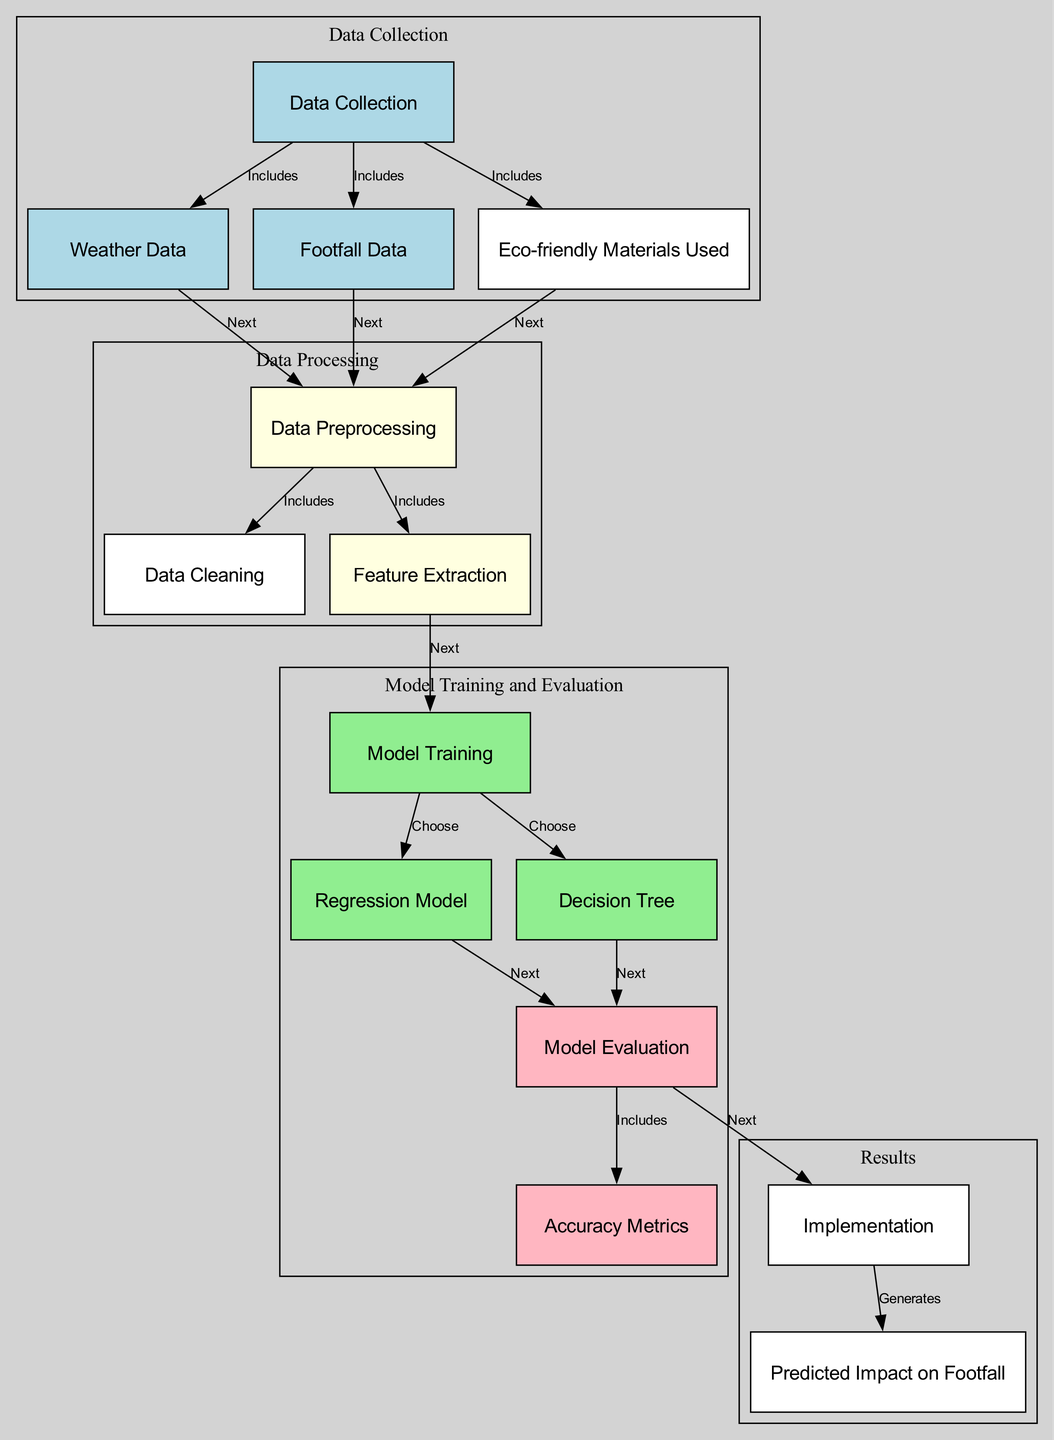What nodes are included in the data collection phase? The diagram directly lists "weather data," "footfall data," and "eco-friendly materials used" as nodes that are part of the data collection phase under the "data_collection" node.
Answer: weather data, footfall data, eco-friendly materials used How many edges connect the preprocessing node? By looking at the diagram, the "preprocessing" node has three outgoing edges that connect to "cleaning," "feature extraction," and the three incoming edges from "weather data," "footfall data," and "eco-friendly materials," making a total of six edges.
Answer: six edges Which model is chosen after model training? The diagram indicates two nodes following "model_training," which are "regression_model" and "decision_tree." Both are options for the model selection.
Answer: regression model, decision tree What are the accuracy metrics examined after evaluation? After the "evaluation" node is completed, it includes an "accuracy metrics" node, which means accuracy metrics are derived from the evaluation phase of the models.
Answer: accuracy metrics What is the final output generated from the implementation phase? According to the diagram, the "implementation" node directly generates the "predicted impact on footfall" as the final analysis result.
Answer: predicted impact on footfall Which step comes first in the data collection? The first node identified under "data_collection" is "weather data," indicating that this is collected first.
Answer: weather data What are the elements included in the data preprocessing step? The diagram shows that after "preprocessing," the nodes "cleaning" and "feature extraction" are included, meaning these activities are part of the preprocessing step.
Answer: cleaning, feature extraction 